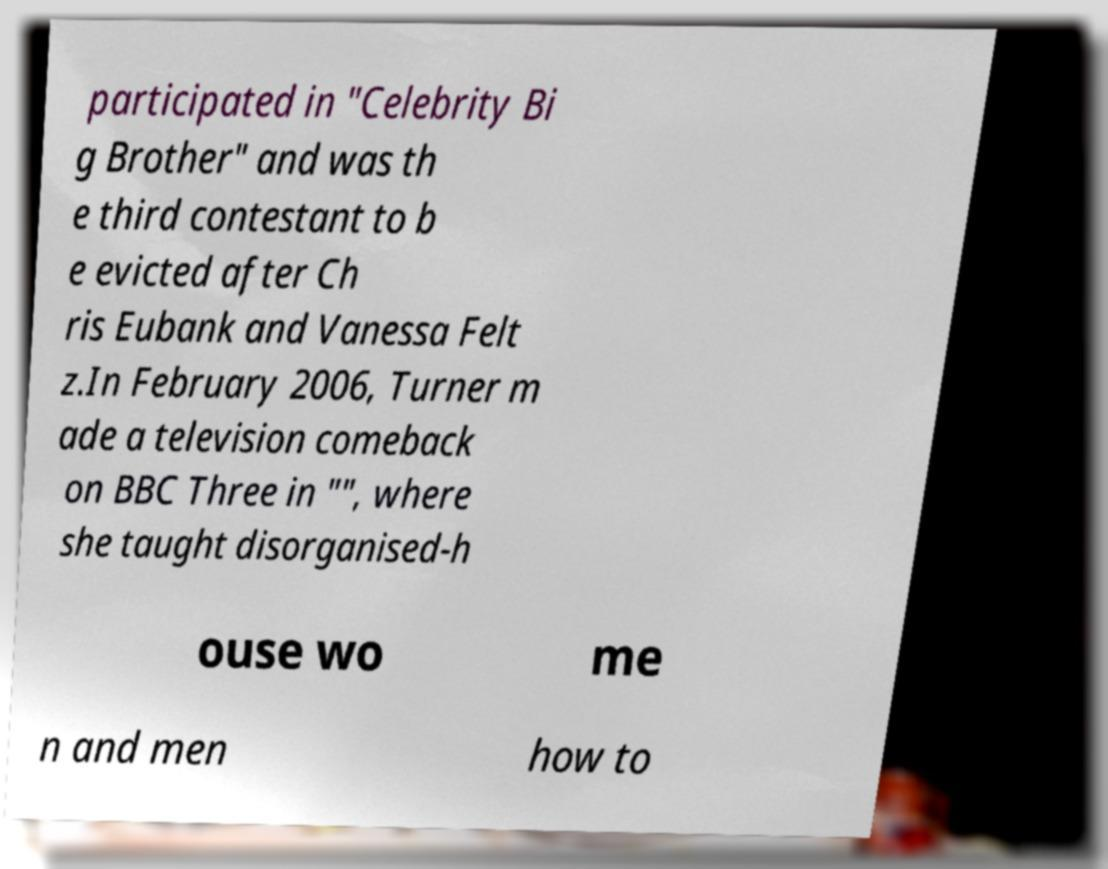Can you read and provide the text displayed in the image?This photo seems to have some interesting text. Can you extract and type it out for me? participated in "Celebrity Bi g Brother" and was th e third contestant to b e evicted after Ch ris Eubank and Vanessa Felt z.In February 2006, Turner m ade a television comeback on BBC Three in "", where she taught disorganised-h ouse wo me n and men how to 